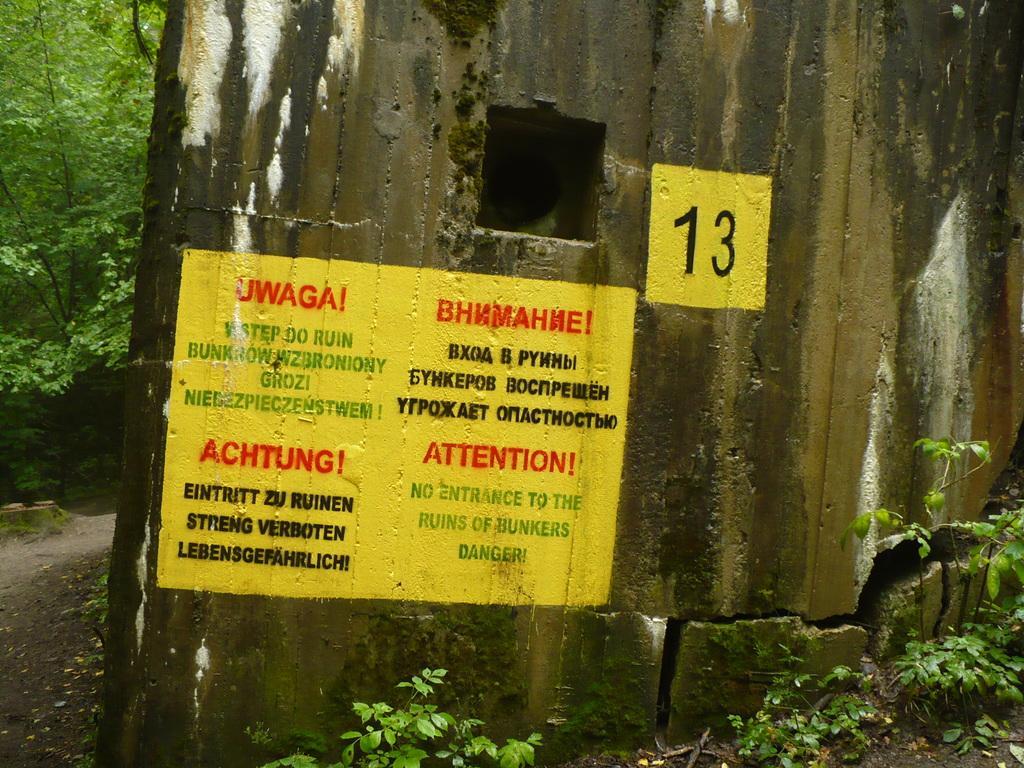In one or two sentences, can you explain what this image depicts? In this picture we can see a wall, on which we can see a painting with text, around we can see some plants and trees. 